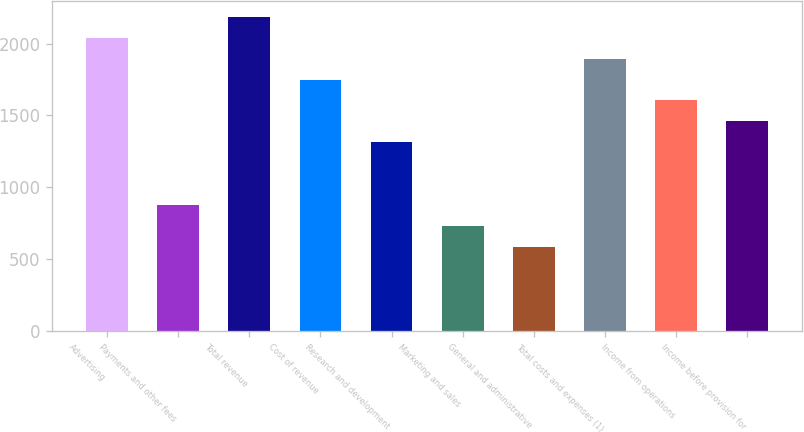<chart> <loc_0><loc_0><loc_500><loc_500><bar_chart><fcel>Advertising<fcel>Payments and other fees<fcel>Total revenue<fcel>Cost of revenue<fcel>Research and development<fcel>Marketing and sales<fcel>General and administrative<fcel>Total costs and expenses (1)<fcel>Income from operations<fcel>Income before provision for<nl><fcel>2041.15<fcel>874.83<fcel>2186.94<fcel>1749.57<fcel>1312.2<fcel>729.04<fcel>583.25<fcel>1895.36<fcel>1603.78<fcel>1457.99<nl></chart> 